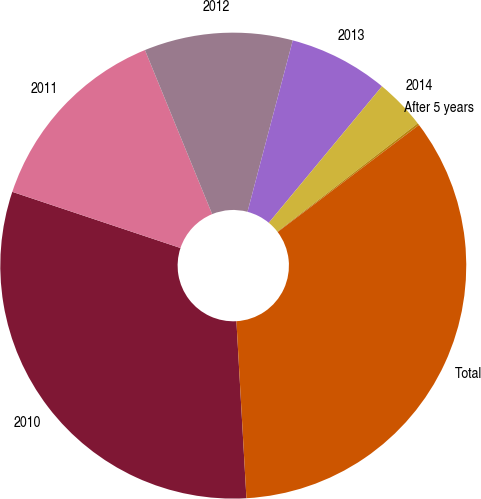Convert chart to OTSL. <chart><loc_0><loc_0><loc_500><loc_500><pie_chart><fcel>2010<fcel>2011<fcel>2012<fcel>2013<fcel>2014<fcel>After 5 years<fcel>Total<nl><fcel>31.03%<fcel>13.68%<fcel>10.3%<fcel>6.91%<fcel>3.52%<fcel>0.14%<fcel>34.42%<nl></chart> 